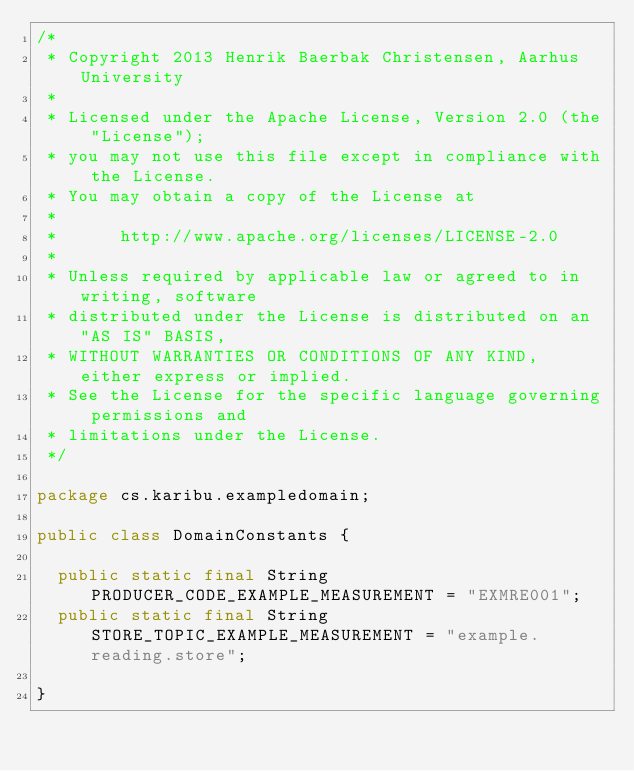Convert code to text. <code><loc_0><loc_0><loc_500><loc_500><_Java_>/*
 * Copyright 2013 Henrik Baerbak Christensen, Aarhus University
 *
 * Licensed under the Apache License, Version 2.0 (the "License");
 * you may not use this file except in compliance with the License.
 * You may obtain a copy of the License at
 *
 *      http://www.apache.org/licenses/LICENSE-2.0
 *
 * Unless required by applicable law or agreed to in writing, software
 * distributed under the License is distributed on an "AS IS" BASIS,
 * WITHOUT WARRANTIES OR CONDITIONS OF ANY KIND, either express or implied.
 * See the License for the specific language governing permissions and
 * limitations under the License.
 */ 

package cs.karibu.exampledomain;

public class DomainConstants {

  public static final String PRODUCER_CODE_EXAMPLE_MEASUREMENT = "EXMRE001";
  public static final String STORE_TOPIC_EXAMPLE_MEASUREMENT = "example.reading.store";

}
</code> 